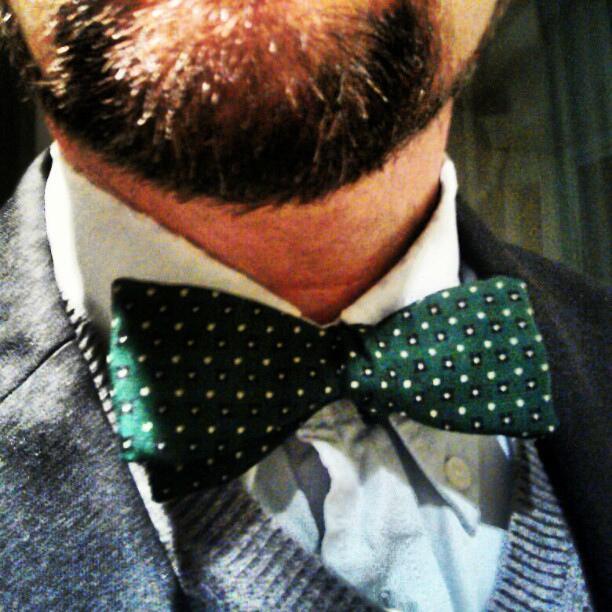What style of shirt is he wearing?
Short answer required. Button up. What type of tie is he wearing?
Give a very brief answer. Bow. Is the man clean-shaven or bearded?
Be succinct. Bearded. 